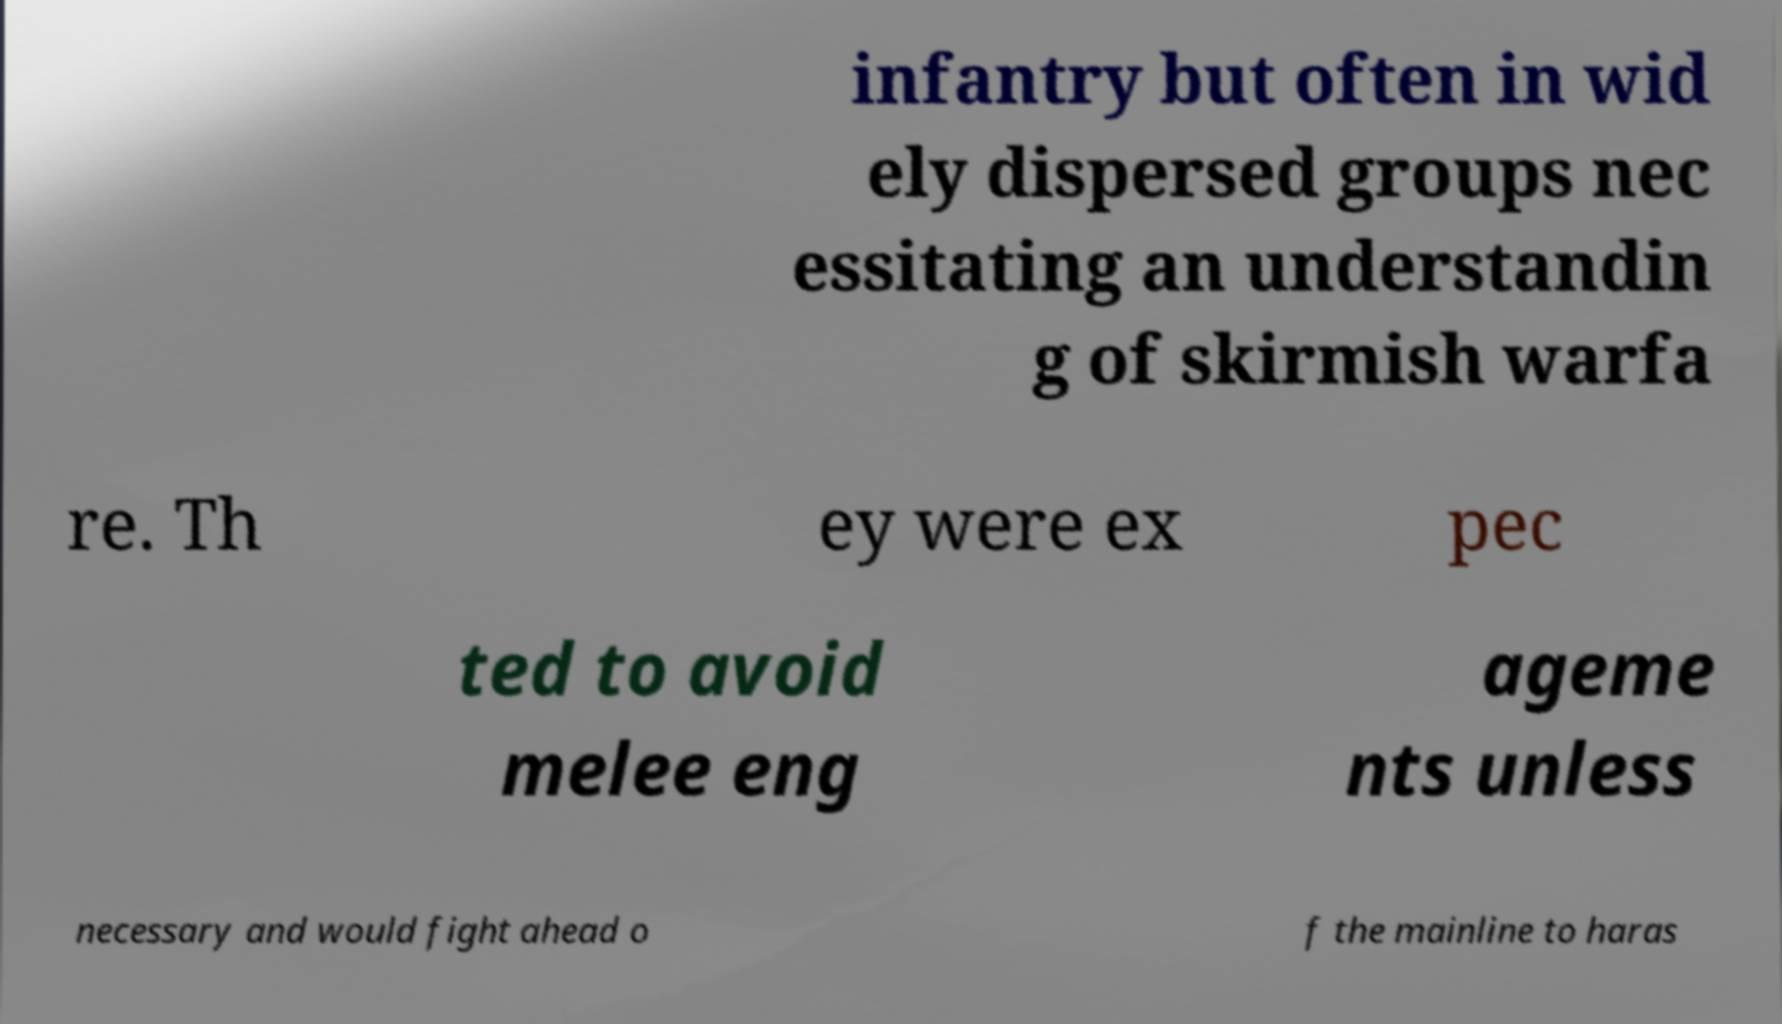Could you assist in decoding the text presented in this image and type it out clearly? infantry but often in wid ely dispersed groups nec essitating an understandin g of skirmish warfa re. Th ey were ex pec ted to avoid melee eng ageme nts unless necessary and would fight ahead o f the mainline to haras 